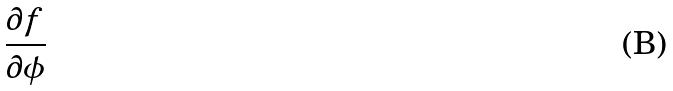Convert formula to latex. <formula><loc_0><loc_0><loc_500><loc_500>\frac { \partial f } { \partial \phi }</formula> 